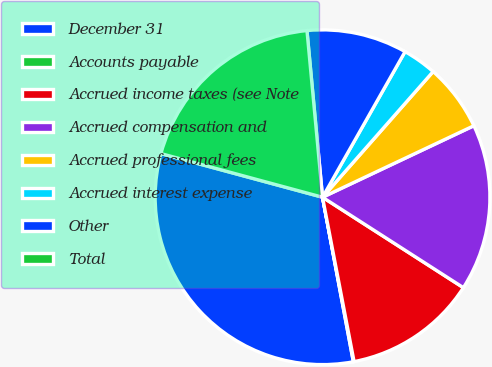<chart> <loc_0><loc_0><loc_500><loc_500><pie_chart><fcel>December 31<fcel>Accounts payable<fcel>Accrued income taxes (see Note<fcel>Accrued compensation and<fcel>Accrued professional fees<fcel>Accrued interest expense<fcel>Other<fcel>Total<nl><fcel>32.15%<fcel>0.07%<fcel>12.9%<fcel>16.11%<fcel>6.49%<fcel>3.28%<fcel>9.69%<fcel>19.32%<nl></chart> 